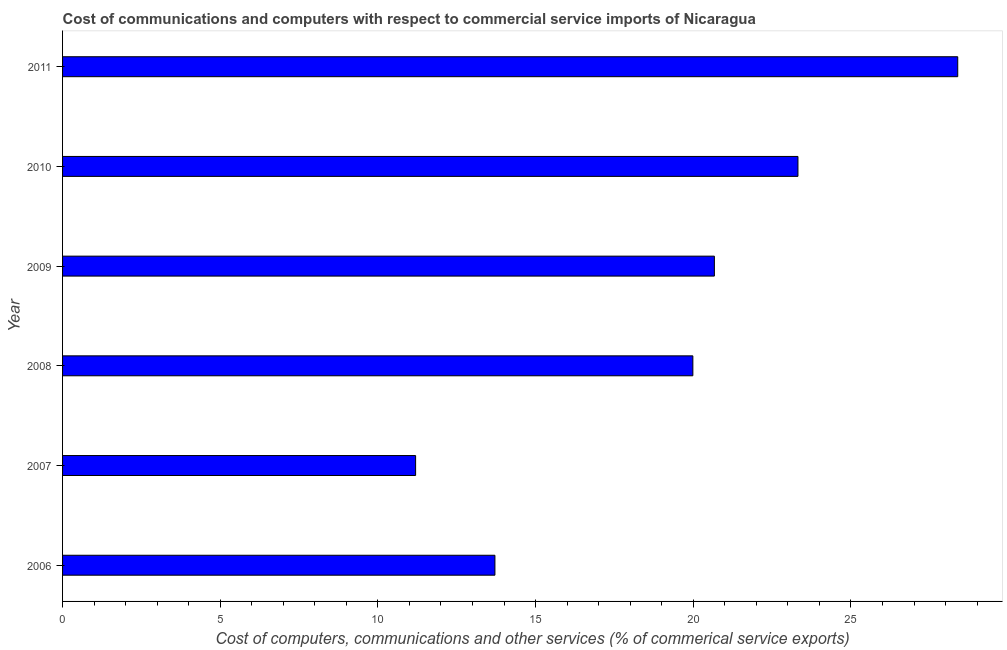Does the graph contain grids?
Give a very brief answer. No. What is the title of the graph?
Make the answer very short. Cost of communications and computers with respect to commercial service imports of Nicaragua. What is the label or title of the X-axis?
Provide a short and direct response. Cost of computers, communications and other services (% of commerical service exports). What is the label or title of the Y-axis?
Your answer should be very brief. Year. What is the  computer and other services in 2010?
Offer a very short reply. 23.32. Across all years, what is the maximum cost of communications?
Provide a succinct answer. 28.39. Across all years, what is the minimum cost of communications?
Ensure brevity in your answer.  11.2. In which year was the cost of communications minimum?
Keep it short and to the point. 2007. What is the sum of the cost of communications?
Your answer should be very brief. 117.27. What is the difference between the cost of communications in 2006 and 2009?
Make the answer very short. -6.96. What is the average  computer and other services per year?
Make the answer very short. 19.55. What is the median cost of communications?
Provide a short and direct response. 20.33. In how many years, is the cost of communications greater than 10 %?
Offer a very short reply. 6. What is the ratio of the cost of communications in 2007 to that in 2008?
Keep it short and to the point. 0.56. Is the cost of communications in 2006 less than that in 2007?
Your answer should be compact. No. Is the difference between the cost of communications in 2006 and 2011 greater than the difference between any two years?
Provide a short and direct response. No. What is the difference between the highest and the second highest cost of communications?
Make the answer very short. 5.07. Is the sum of the  computer and other services in 2009 and 2010 greater than the maximum  computer and other services across all years?
Make the answer very short. Yes. What is the difference between the highest and the lowest  computer and other services?
Offer a very short reply. 17.19. In how many years, is the cost of communications greater than the average cost of communications taken over all years?
Your response must be concise. 4. How many bars are there?
Provide a succinct answer. 6. Are all the bars in the graph horizontal?
Give a very brief answer. Yes. How many years are there in the graph?
Give a very brief answer. 6. What is the difference between two consecutive major ticks on the X-axis?
Your response must be concise. 5. What is the Cost of computers, communications and other services (% of commerical service exports) in 2006?
Make the answer very short. 13.71. What is the Cost of computers, communications and other services (% of commerical service exports) in 2007?
Ensure brevity in your answer.  11.2. What is the Cost of computers, communications and other services (% of commerical service exports) in 2008?
Give a very brief answer. 19.99. What is the Cost of computers, communications and other services (% of commerical service exports) in 2009?
Keep it short and to the point. 20.67. What is the Cost of computers, communications and other services (% of commerical service exports) of 2010?
Your answer should be very brief. 23.32. What is the Cost of computers, communications and other services (% of commerical service exports) of 2011?
Offer a terse response. 28.39. What is the difference between the Cost of computers, communications and other services (% of commerical service exports) in 2006 and 2007?
Keep it short and to the point. 2.52. What is the difference between the Cost of computers, communications and other services (% of commerical service exports) in 2006 and 2008?
Provide a succinct answer. -6.28. What is the difference between the Cost of computers, communications and other services (% of commerical service exports) in 2006 and 2009?
Make the answer very short. -6.96. What is the difference between the Cost of computers, communications and other services (% of commerical service exports) in 2006 and 2010?
Give a very brief answer. -9.61. What is the difference between the Cost of computers, communications and other services (% of commerical service exports) in 2006 and 2011?
Keep it short and to the point. -14.68. What is the difference between the Cost of computers, communications and other services (% of commerical service exports) in 2007 and 2008?
Your answer should be compact. -8.79. What is the difference between the Cost of computers, communications and other services (% of commerical service exports) in 2007 and 2009?
Offer a very short reply. -9.47. What is the difference between the Cost of computers, communications and other services (% of commerical service exports) in 2007 and 2010?
Your response must be concise. -12.12. What is the difference between the Cost of computers, communications and other services (% of commerical service exports) in 2007 and 2011?
Your response must be concise. -17.19. What is the difference between the Cost of computers, communications and other services (% of commerical service exports) in 2008 and 2009?
Ensure brevity in your answer.  -0.68. What is the difference between the Cost of computers, communications and other services (% of commerical service exports) in 2008 and 2010?
Your answer should be compact. -3.33. What is the difference between the Cost of computers, communications and other services (% of commerical service exports) in 2008 and 2011?
Give a very brief answer. -8.4. What is the difference between the Cost of computers, communications and other services (% of commerical service exports) in 2009 and 2010?
Your answer should be very brief. -2.65. What is the difference between the Cost of computers, communications and other services (% of commerical service exports) in 2009 and 2011?
Ensure brevity in your answer.  -7.72. What is the difference between the Cost of computers, communications and other services (% of commerical service exports) in 2010 and 2011?
Provide a short and direct response. -5.07. What is the ratio of the Cost of computers, communications and other services (% of commerical service exports) in 2006 to that in 2007?
Keep it short and to the point. 1.23. What is the ratio of the Cost of computers, communications and other services (% of commerical service exports) in 2006 to that in 2008?
Give a very brief answer. 0.69. What is the ratio of the Cost of computers, communications and other services (% of commerical service exports) in 2006 to that in 2009?
Your answer should be compact. 0.66. What is the ratio of the Cost of computers, communications and other services (% of commerical service exports) in 2006 to that in 2010?
Offer a terse response. 0.59. What is the ratio of the Cost of computers, communications and other services (% of commerical service exports) in 2006 to that in 2011?
Offer a very short reply. 0.48. What is the ratio of the Cost of computers, communications and other services (% of commerical service exports) in 2007 to that in 2008?
Offer a terse response. 0.56. What is the ratio of the Cost of computers, communications and other services (% of commerical service exports) in 2007 to that in 2009?
Offer a very short reply. 0.54. What is the ratio of the Cost of computers, communications and other services (% of commerical service exports) in 2007 to that in 2010?
Your response must be concise. 0.48. What is the ratio of the Cost of computers, communications and other services (% of commerical service exports) in 2007 to that in 2011?
Provide a succinct answer. 0.39. What is the ratio of the Cost of computers, communications and other services (% of commerical service exports) in 2008 to that in 2009?
Provide a short and direct response. 0.97. What is the ratio of the Cost of computers, communications and other services (% of commerical service exports) in 2008 to that in 2010?
Your answer should be very brief. 0.86. What is the ratio of the Cost of computers, communications and other services (% of commerical service exports) in 2008 to that in 2011?
Keep it short and to the point. 0.7. What is the ratio of the Cost of computers, communications and other services (% of commerical service exports) in 2009 to that in 2010?
Your answer should be compact. 0.89. What is the ratio of the Cost of computers, communications and other services (% of commerical service exports) in 2009 to that in 2011?
Offer a terse response. 0.73. What is the ratio of the Cost of computers, communications and other services (% of commerical service exports) in 2010 to that in 2011?
Your answer should be very brief. 0.82. 